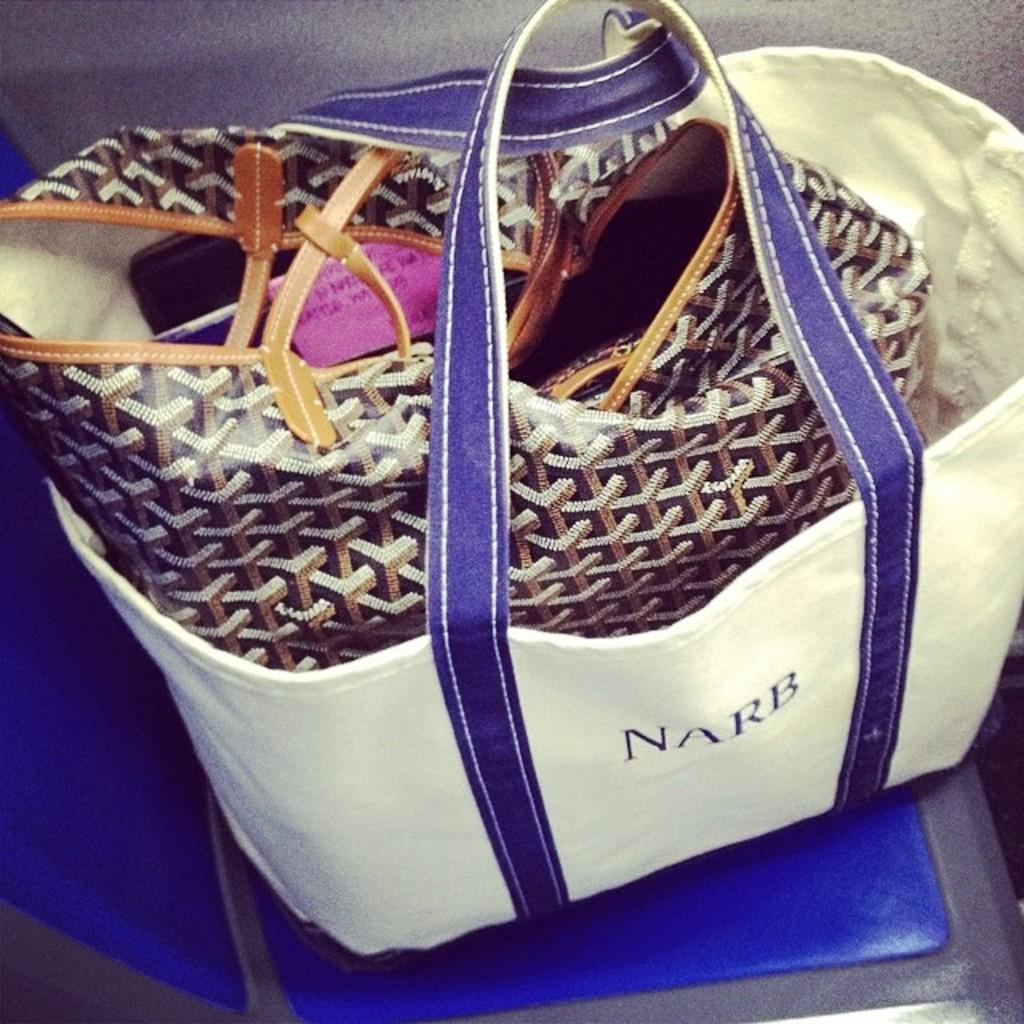What is placed on the chair in the image? There is a bag on a chair in the image. What colors are visible on the bag? The bag has a white and blue color. What is inside the bag on the chair? There is another bag inside the first bag. What color is the second bag? The second bag has a chocolate color. What color is the chair the bag is placed on? The chair has a blue color. Are there any boats visible in the image? There are no boats present in the image. What type of border can be seen around the bag? There is no border visible around the bag in the image. 